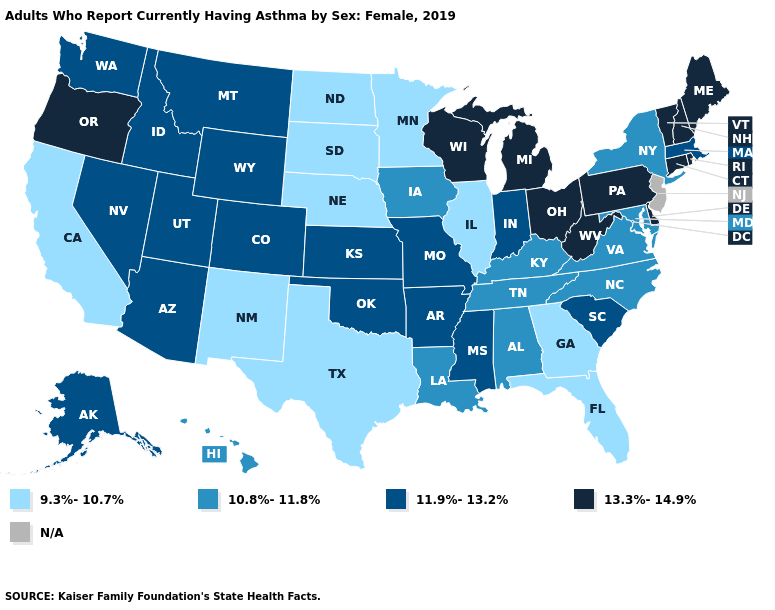Name the states that have a value in the range 13.3%-14.9%?
Keep it brief. Connecticut, Delaware, Maine, Michigan, New Hampshire, Ohio, Oregon, Pennsylvania, Rhode Island, Vermont, West Virginia, Wisconsin. Name the states that have a value in the range 10.8%-11.8%?
Concise answer only. Alabama, Hawaii, Iowa, Kentucky, Louisiana, Maryland, New York, North Carolina, Tennessee, Virginia. Among the states that border Georgia , which have the highest value?
Answer briefly. South Carolina. Does Louisiana have the highest value in the USA?
Answer briefly. No. What is the value of Mississippi?
Answer briefly. 11.9%-13.2%. Does West Virginia have the highest value in the USA?
Keep it brief. Yes. Name the states that have a value in the range N/A?
Give a very brief answer. New Jersey. Name the states that have a value in the range 10.8%-11.8%?
Keep it brief. Alabama, Hawaii, Iowa, Kentucky, Louisiana, Maryland, New York, North Carolina, Tennessee, Virginia. Does Delaware have the highest value in the USA?
Quick response, please. Yes. What is the value of New Jersey?
Quick response, please. N/A. Among the states that border North Dakota , does Minnesota have the lowest value?
Short answer required. Yes. What is the value of North Dakota?
Be succinct. 9.3%-10.7%. Does Wisconsin have the highest value in the USA?
Give a very brief answer. Yes. What is the value of Kansas?
Write a very short answer. 11.9%-13.2%. What is the value of Indiana?
Write a very short answer. 11.9%-13.2%. 